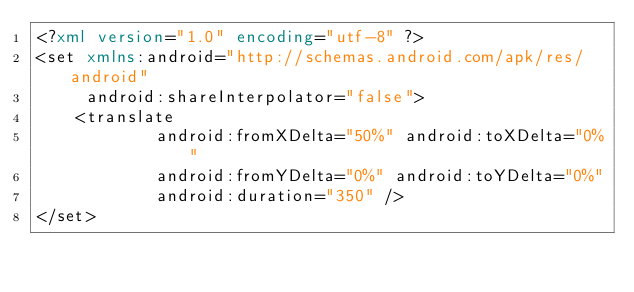Convert code to text. <code><loc_0><loc_0><loc_500><loc_500><_XML_><?xml version="1.0" encoding="utf-8" ?>
<set xmlns:android="http://schemas.android.com/apk/res/android"
     android:shareInterpolator="false">
    <translate
            android:fromXDelta="50%" android:toXDelta="0%"
            android:fromYDelta="0%" android:toYDelta="0%"
            android:duration="350" />
</set></code> 